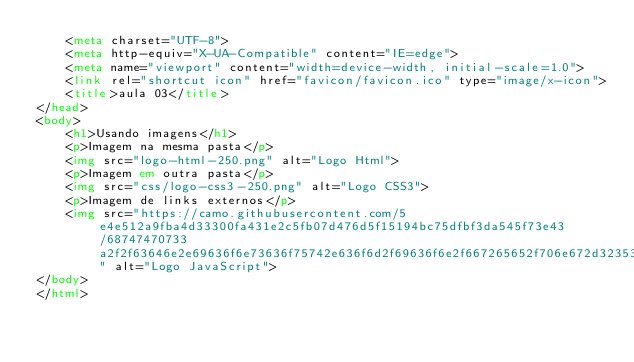<code> <loc_0><loc_0><loc_500><loc_500><_HTML_>    <meta charset="UTF-8">
    <meta http-equiv="X-UA-Compatible" content="IE=edge">
    <meta name="viewport" content="width=device-width, initial-scale=1.0">
    <link rel="shortcut icon" href="favicon/favicon.ico" type="image/x-icon">
    <title>aula 03</title>
</head>
<body>
    <h1>Usando imagens</h1>
    <p>Imagem na mesma pasta</p>
    <img src="logo-html-250.png" alt="Logo Html">
    <p>Imagem em outra pasta</p>
    <img src="css/logo-css3-250.png" alt="Logo CSS3">
    <p>Imagem de links externos</p>
    <img src="https://camo.githubusercontent.com/5e4e512a9fba4d33300fa431e2c5fb07d476d5f15194bc75dfbf3da545f73e43/68747470733a2f2f63646e2e69636f6e73636f75742e636f6d2f69636f6e2f667265652f706e672d3235362f6a6176617363726970742d323735323134382d323238343936352e706e67" alt="Logo JavaScript">
</body>
</html></code> 